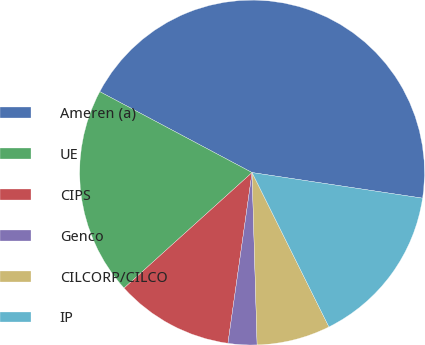Convert chart to OTSL. <chart><loc_0><loc_0><loc_500><loc_500><pie_chart><fcel>Ameren (a)<fcel>UE<fcel>CIPS<fcel>Genco<fcel>CILCORP/CILCO<fcel>IP<nl><fcel>44.6%<fcel>19.46%<fcel>11.08%<fcel>2.7%<fcel>6.89%<fcel>15.27%<nl></chart> 